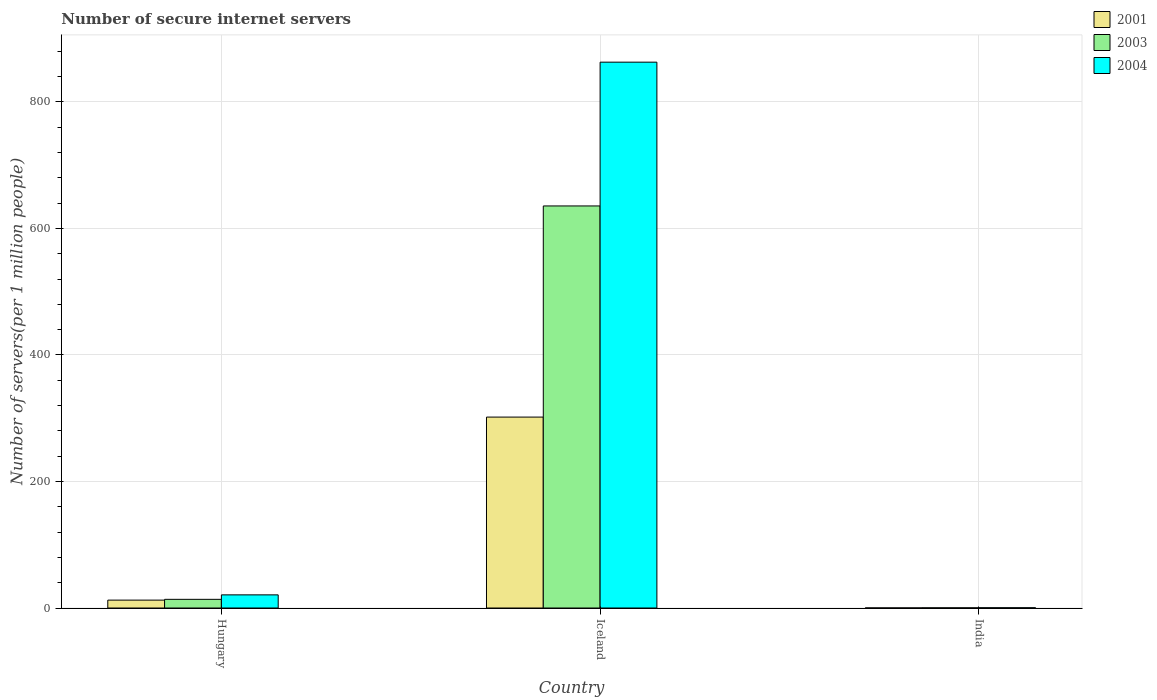How many groups of bars are there?
Offer a very short reply. 3. Are the number of bars per tick equal to the number of legend labels?
Your answer should be compact. Yes. Are the number of bars on each tick of the X-axis equal?
Your response must be concise. Yes. How many bars are there on the 1st tick from the right?
Provide a succinct answer. 3. What is the label of the 2nd group of bars from the left?
Your answer should be compact. Iceland. In how many cases, is the number of bars for a given country not equal to the number of legend labels?
Offer a very short reply. 0. What is the number of secure internet servers in 2001 in Hungary?
Offer a terse response. 12.47. Across all countries, what is the maximum number of secure internet servers in 2003?
Offer a terse response. 635.53. Across all countries, what is the minimum number of secure internet servers in 2001?
Ensure brevity in your answer.  0.11. In which country was the number of secure internet servers in 2001 maximum?
Your answer should be compact. Iceland. In which country was the number of secure internet servers in 2003 minimum?
Ensure brevity in your answer.  India. What is the total number of secure internet servers in 2001 in the graph?
Your answer should be very brief. 314.37. What is the difference between the number of secure internet servers in 2003 in Iceland and that in India?
Your answer should be very brief. 635.28. What is the difference between the number of secure internet servers in 2001 in Hungary and the number of secure internet servers in 2003 in Iceland?
Give a very brief answer. -623.07. What is the average number of secure internet servers in 2001 per country?
Your response must be concise. 104.79. What is the difference between the number of secure internet servers of/in 2003 and number of secure internet servers of/in 2004 in Iceland?
Offer a terse response. -227.26. In how many countries, is the number of secure internet servers in 2003 greater than 760?
Give a very brief answer. 0. What is the ratio of the number of secure internet servers in 2003 in Hungary to that in Iceland?
Provide a succinct answer. 0.02. What is the difference between the highest and the second highest number of secure internet servers in 2003?
Offer a very short reply. -635.28. What is the difference between the highest and the lowest number of secure internet servers in 2003?
Your answer should be very brief. 635.28. What does the 2nd bar from the right in Hungary represents?
Ensure brevity in your answer.  2003. Is it the case that in every country, the sum of the number of secure internet servers in 2003 and number of secure internet servers in 2004 is greater than the number of secure internet servers in 2001?
Provide a short and direct response. Yes. Are all the bars in the graph horizontal?
Keep it short and to the point. No. Are the values on the major ticks of Y-axis written in scientific E-notation?
Provide a succinct answer. No. Where does the legend appear in the graph?
Your answer should be very brief. Top right. How many legend labels are there?
Your answer should be very brief. 3. How are the legend labels stacked?
Ensure brevity in your answer.  Vertical. What is the title of the graph?
Your answer should be very brief. Number of secure internet servers. What is the label or title of the Y-axis?
Your response must be concise. Number of servers(per 1 million people). What is the Number of servers(per 1 million people) in 2001 in Hungary?
Make the answer very short. 12.47. What is the Number of servers(per 1 million people) in 2003 in Hungary?
Keep it short and to the point. 13.72. What is the Number of servers(per 1 million people) in 2004 in Hungary?
Give a very brief answer. 20.78. What is the Number of servers(per 1 million people) of 2001 in Iceland?
Provide a short and direct response. 301.79. What is the Number of servers(per 1 million people) in 2003 in Iceland?
Keep it short and to the point. 635.53. What is the Number of servers(per 1 million people) of 2004 in Iceland?
Your answer should be very brief. 862.8. What is the Number of servers(per 1 million people) of 2001 in India?
Ensure brevity in your answer.  0.11. What is the Number of servers(per 1 million people) in 2003 in India?
Your answer should be very brief. 0.25. What is the Number of servers(per 1 million people) of 2004 in India?
Offer a terse response. 0.41. Across all countries, what is the maximum Number of servers(per 1 million people) in 2001?
Keep it short and to the point. 301.79. Across all countries, what is the maximum Number of servers(per 1 million people) of 2003?
Offer a very short reply. 635.53. Across all countries, what is the maximum Number of servers(per 1 million people) of 2004?
Give a very brief answer. 862.8. Across all countries, what is the minimum Number of servers(per 1 million people) of 2001?
Keep it short and to the point. 0.11. Across all countries, what is the minimum Number of servers(per 1 million people) of 2003?
Provide a succinct answer. 0.25. Across all countries, what is the minimum Number of servers(per 1 million people) of 2004?
Your answer should be compact. 0.41. What is the total Number of servers(per 1 million people) of 2001 in the graph?
Keep it short and to the point. 314.37. What is the total Number of servers(per 1 million people) in 2003 in the graph?
Your answer should be compact. 649.51. What is the total Number of servers(per 1 million people) of 2004 in the graph?
Give a very brief answer. 883.98. What is the difference between the Number of servers(per 1 million people) in 2001 in Hungary and that in Iceland?
Offer a terse response. -289.32. What is the difference between the Number of servers(per 1 million people) of 2003 in Hungary and that in Iceland?
Offer a terse response. -621.81. What is the difference between the Number of servers(per 1 million people) in 2004 in Hungary and that in Iceland?
Ensure brevity in your answer.  -842.02. What is the difference between the Number of servers(per 1 million people) in 2001 in Hungary and that in India?
Offer a terse response. 12.35. What is the difference between the Number of servers(per 1 million people) of 2003 in Hungary and that in India?
Keep it short and to the point. 13.47. What is the difference between the Number of servers(per 1 million people) of 2004 in Hungary and that in India?
Provide a succinct answer. 20.37. What is the difference between the Number of servers(per 1 million people) of 2001 in Iceland and that in India?
Ensure brevity in your answer.  301.67. What is the difference between the Number of servers(per 1 million people) in 2003 in Iceland and that in India?
Offer a terse response. 635.28. What is the difference between the Number of servers(per 1 million people) in 2004 in Iceland and that in India?
Give a very brief answer. 862.38. What is the difference between the Number of servers(per 1 million people) in 2001 in Hungary and the Number of servers(per 1 million people) in 2003 in Iceland?
Offer a very short reply. -623.07. What is the difference between the Number of servers(per 1 million people) of 2001 in Hungary and the Number of servers(per 1 million people) of 2004 in Iceland?
Your response must be concise. -850.33. What is the difference between the Number of servers(per 1 million people) of 2003 in Hungary and the Number of servers(per 1 million people) of 2004 in Iceland?
Offer a very short reply. -849.07. What is the difference between the Number of servers(per 1 million people) in 2001 in Hungary and the Number of servers(per 1 million people) in 2003 in India?
Your answer should be very brief. 12.21. What is the difference between the Number of servers(per 1 million people) in 2001 in Hungary and the Number of servers(per 1 million people) in 2004 in India?
Give a very brief answer. 12.06. What is the difference between the Number of servers(per 1 million people) in 2003 in Hungary and the Number of servers(per 1 million people) in 2004 in India?
Provide a short and direct response. 13.31. What is the difference between the Number of servers(per 1 million people) in 2001 in Iceland and the Number of servers(per 1 million people) in 2003 in India?
Your response must be concise. 301.53. What is the difference between the Number of servers(per 1 million people) of 2001 in Iceland and the Number of servers(per 1 million people) of 2004 in India?
Provide a short and direct response. 301.38. What is the difference between the Number of servers(per 1 million people) in 2003 in Iceland and the Number of servers(per 1 million people) in 2004 in India?
Provide a short and direct response. 635.12. What is the average Number of servers(per 1 million people) in 2001 per country?
Your answer should be very brief. 104.79. What is the average Number of servers(per 1 million people) of 2003 per country?
Give a very brief answer. 216.5. What is the average Number of servers(per 1 million people) in 2004 per country?
Offer a very short reply. 294.66. What is the difference between the Number of servers(per 1 million people) in 2001 and Number of servers(per 1 million people) in 2003 in Hungary?
Offer a very short reply. -1.26. What is the difference between the Number of servers(per 1 million people) in 2001 and Number of servers(per 1 million people) in 2004 in Hungary?
Ensure brevity in your answer.  -8.31. What is the difference between the Number of servers(per 1 million people) of 2003 and Number of servers(per 1 million people) of 2004 in Hungary?
Provide a succinct answer. -7.06. What is the difference between the Number of servers(per 1 million people) in 2001 and Number of servers(per 1 million people) in 2003 in Iceland?
Your answer should be very brief. -333.74. What is the difference between the Number of servers(per 1 million people) of 2001 and Number of servers(per 1 million people) of 2004 in Iceland?
Make the answer very short. -561.01. What is the difference between the Number of servers(per 1 million people) in 2003 and Number of servers(per 1 million people) in 2004 in Iceland?
Make the answer very short. -227.26. What is the difference between the Number of servers(per 1 million people) of 2001 and Number of servers(per 1 million people) of 2003 in India?
Your answer should be compact. -0.14. What is the difference between the Number of servers(per 1 million people) in 2001 and Number of servers(per 1 million people) in 2004 in India?
Provide a short and direct response. -0.3. What is the difference between the Number of servers(per 1 million people) in 2003 and Number of servers(per 1 million people) in 2004 in India?
Offer a very short reply. -0.16. What is the ratio of the Number of servers(per 1 million people) in 2001 in Hungary to that in Iceland?
Provide a succinct answer. 0.04. What is the ratio of the Number of servers(per 1 million people) of 2003 in Hungary to that in Iceland?
Your response must be concise. 0.02. What is the ratio of the Number of servers(per 1 million people) in 2004 in Hungary to that in Iceland?
Your response must be concise. 0.02. What is the ratio of the Number of servers(per 1 million people) in 2001 in Hungary to that in India?
Your answer should be very brief. 109.53. What is the ratio of the Number of servers(per 1 million people) of 2003 in Hungary to that in India?
Provide a succinct answer. 54.13. What is the ratio of the Number of servers(per 1 million people) in 2004 in Hungary to that in India?
Keep it short and to the point. 50.66. What is the ratio of the Number of servers(per 1 million people) in 2001 in Iceland to that in India?
Make the answer very short. 2651.5. What is the ratio of the Number of servers(per 1 million people) of 2003 in Iceland to that in India?
Ensure brevity in your answer.  2506.78. What is the ratio of the Number of servers(per 1 million people) of 2004 in Iceland to that in India?
Your response must be concise. 2103.61. What is the difference between the highest and the second highest Number of servers(per 1 million people) in 2001?
Your response must be concise. 289.32. What is the difference between the highest and the second highest Number of servers(per 1 million people) in 2003?
Your answer should be compact. 621.81. What is the difference between the highest and the second highest Number of servers(per 1 million people) of 2004?
Provide a succinct answer. 842.02. What is the difference between the highest and the lowest Number of servers(per 1 million people) of 2001?
Your response must be concise. 301.67. What is the difference between the highest and the lowest Number of servers(per 1 million people) of 2003?
Offer a terse response. 635.28. What is the difference between the highest and the lowest Number of servers(per 1 million people) of 2004?
Offer a very short reply. 862.38. 